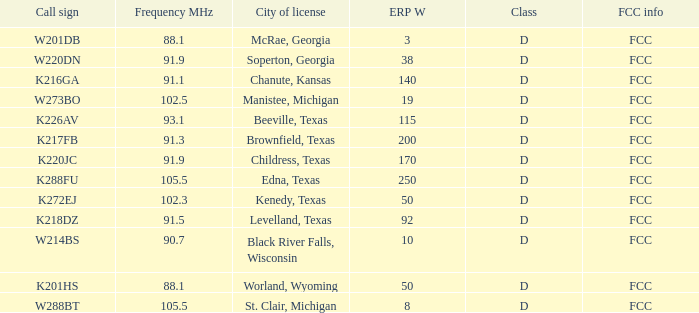What is the call sign when the city of permit is brownfield, texas? K217FB. 